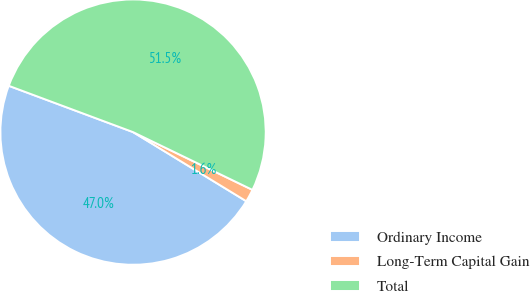Convert chart to OTSL. <chart><loc_0><loc_0><loc_500><loc_500><pie_chart><fcel>Ordinary Income<fcel>Long-Term Capital Gain<fcel>Total<nl><fcel>46.95%<fcel>1.55%<fcel>51.49%<nl></chart> 